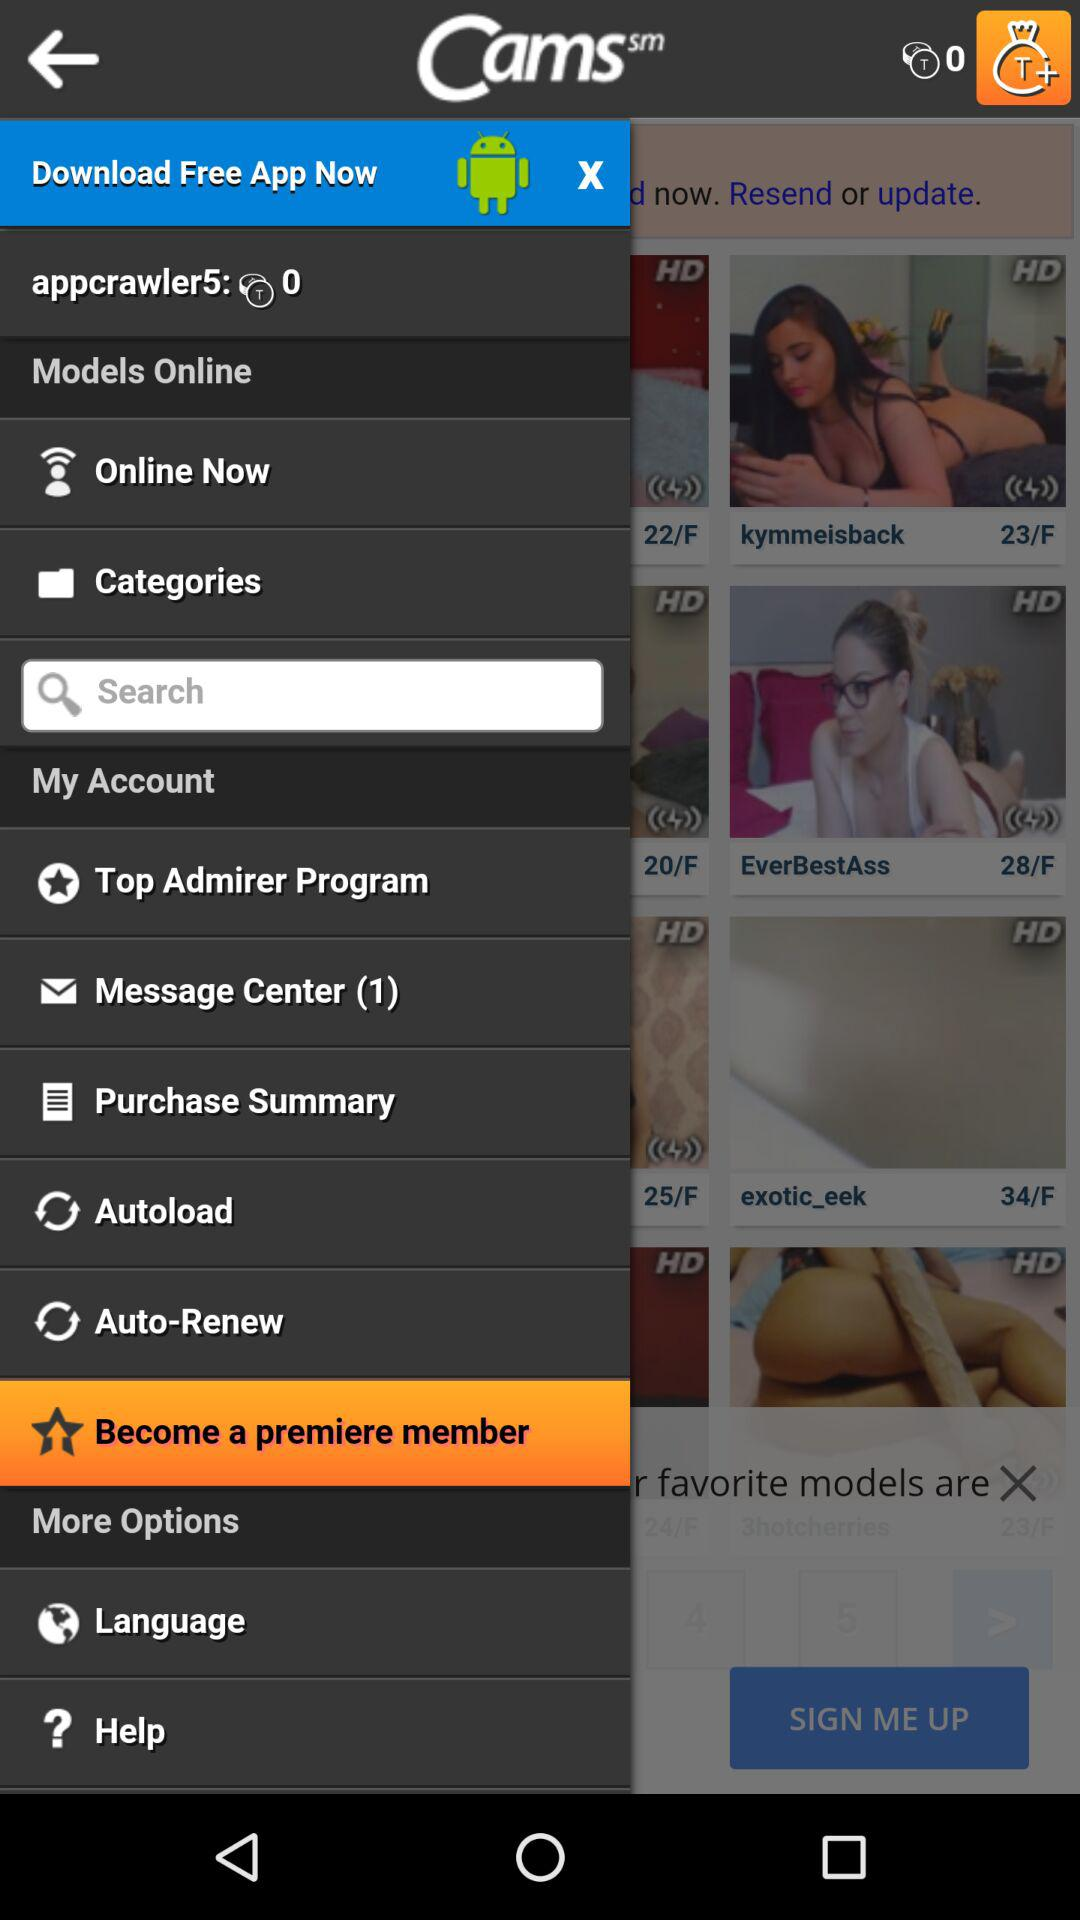What is the name of the application? The name of the application is "Cams". 